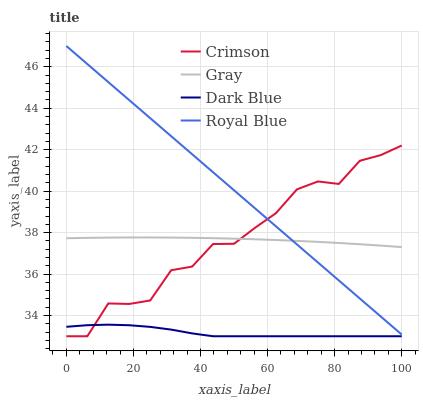Does Dark Blue have the minimum area under the curve?
Answer yes or no. Yes. Does Royal Blue have the maximum area under the curve?
Answer yes or no. Yes. Does Gray have the minimum area under the curve?
Answer yes or no. No. Does Gray have the maximum area under the curve?
Answer yes or no. No. Is Royal Blue the smoothest?
Answer yes or no. Yes. Is Crimson the roughest?
Answer yes or no. Yes. Is Gray the smoothest?
Answer yes or no. No. Is Gray the roughest?
Answer yes or no. No. Does Crimson have the lowest value?
Answer yes or no. Yes. Does Royal Blue have the lowest value?
Answer yes or no. No. Does Royal Blue have the highest value?
Answer yes or no. Yes. Does Gray have the highest value?
Answer yes or no. No. Is Dark Blue less than Royal Blue?
Answer yes or no. Yes. Is Gray greater than Dark Blue?
Answer yes or no. Yes. Does Crimson intersect Dark Blue?
Answer yes or no. Yes. Is Crimson less than Dark Blue?
Answer yes or no. No. Is Crimson greater than Dark Blue?
Answer yes or no. No. Does Dark Blue intersect Royal Blue?
Answer yes or no. No. 